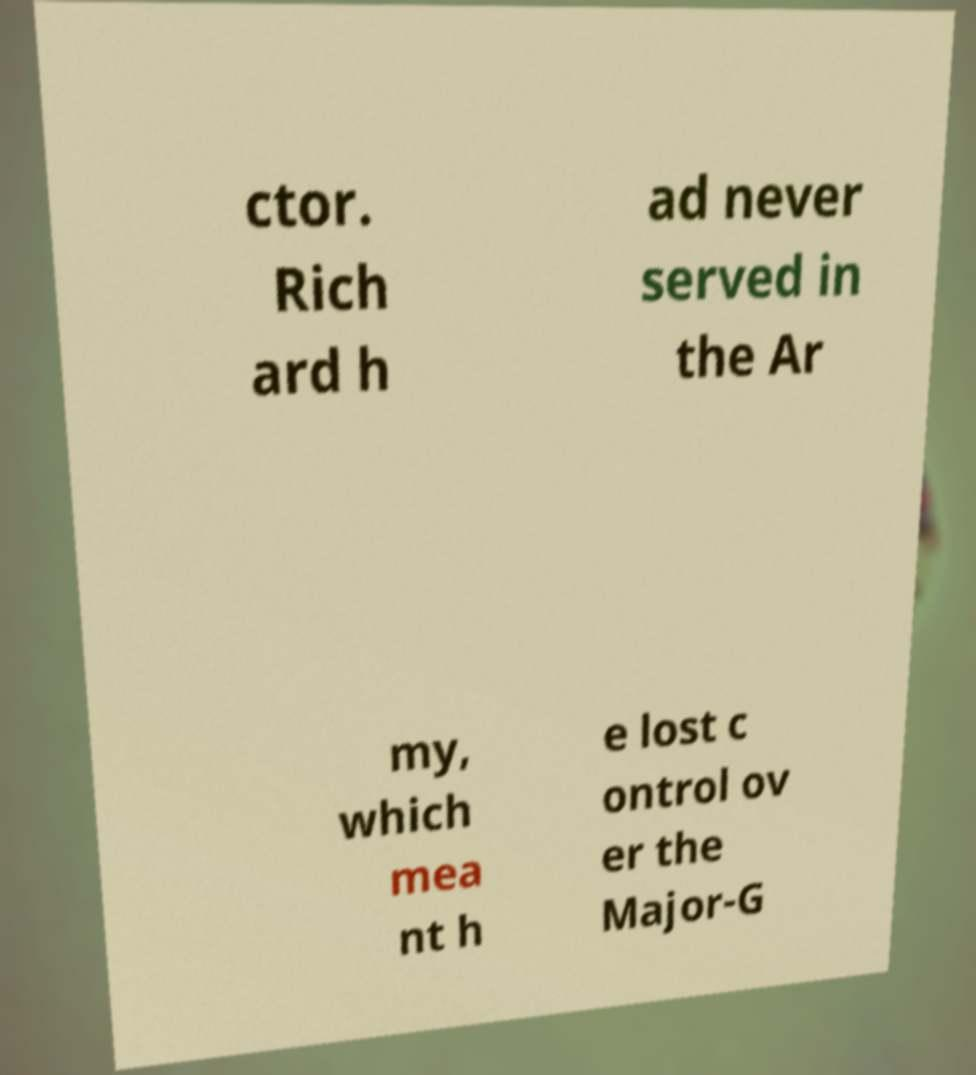Could you extract and type out the text from this image? ctor. Rich ard h ad never served in the Ar my, which mea nt h e lost c ontrol ov er the Major-G 